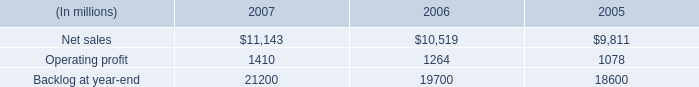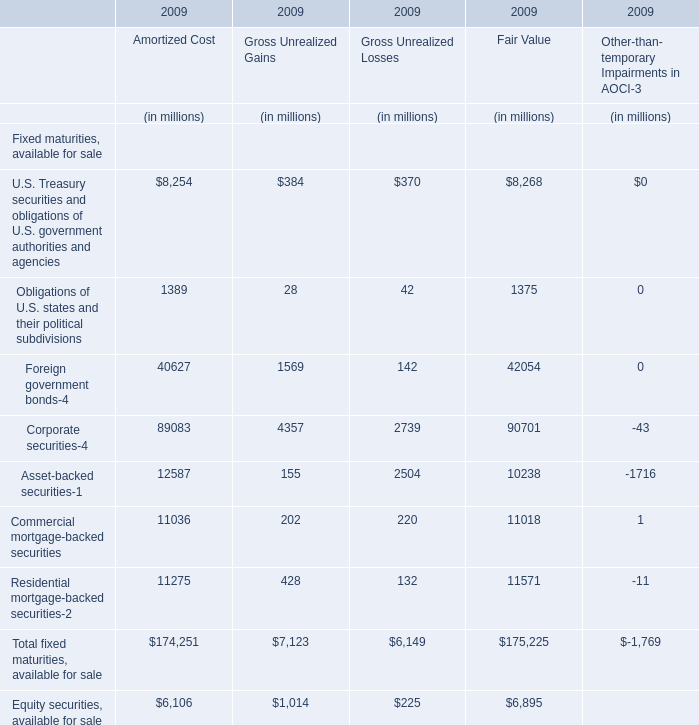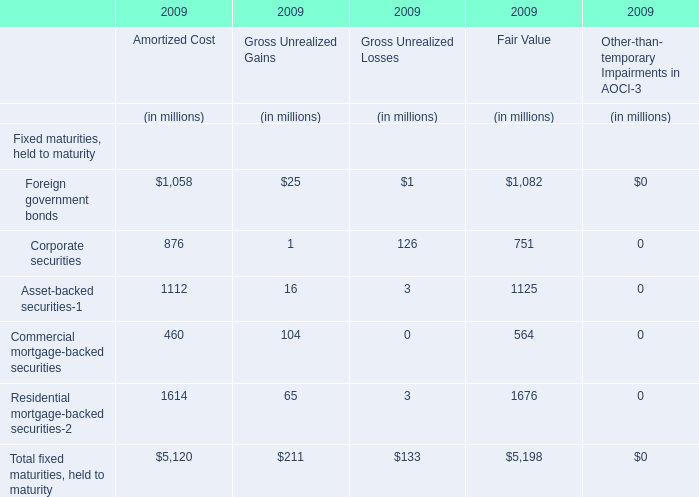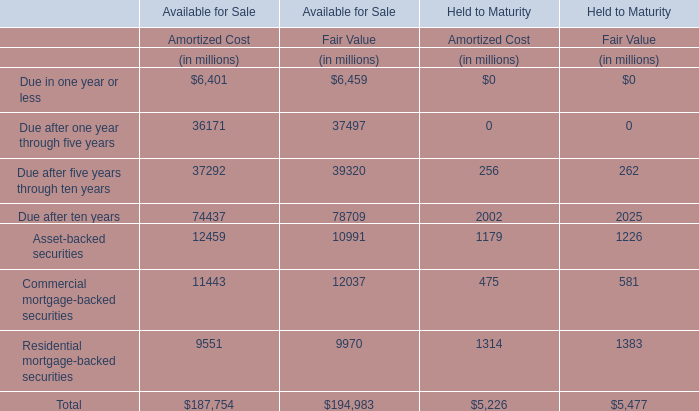In which year is U.S. Treasury securities and obligations of U.S. government authorities and agencies greater than 1000? 
Computations: (8254 + 8268)
Answer: 16522.0. 